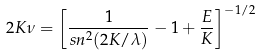Convert formula to latex. <formula><loc_0><loc_0><loc_500><loc_500>2 K \nu = \left [ \frac { 1 } { s n ^ { 2 } ( 2 K / \lambda ) } - 1 + \frac { E } { K } \right ] ^ { - 1 / 2 }</formula> 